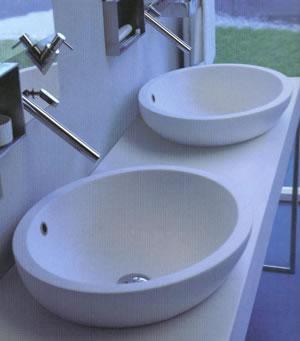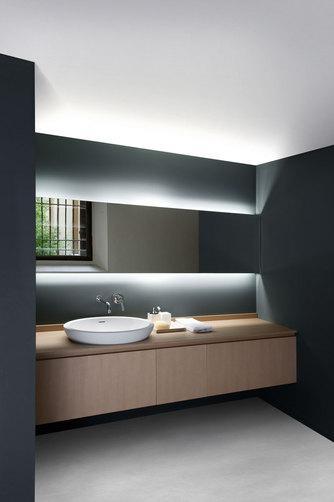The first image is the image on the left, the second image is the image on the right. Evaluate the accuracy of this statement regarding the images: "There are exactly two faucets.". Is it true? Answer yes or no. No. The first image is the image on the left, the second image is the image on the right. For the images displayed, is the sentence "An image shows a wall-mounted beige vanity with opened shelf section containing stacks of white towels." factually correct? Answer yes or no. No. The first image is the image on the left, the second image is the image on the right. Examine the images to the left and right. Is the description "In one image, a wide box-like vanity attached to the wall has a white sink installed at one end, while the opposite end is open, showing towel storage." accurate? Answer yes or no. No. The first image is the image on the left, the second image is the image on the right. Analyze the images presented: Is the assertion "The left image features an aerial view of a rounded white uninstalled sink, and the right views shows the same sink shape on a counter under a black ledge with at least one bottle at the end of it." valid? Answer yes or no. No. 